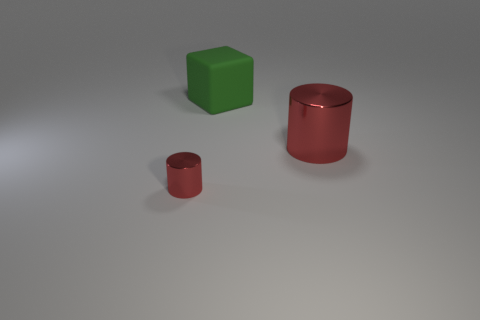Is there any other thing that is the same material as the big green object?
Offer a very short reply. No. There is a large object that is to the left of the big shiny thing; what is it made of?
Provide a succinct answer. Rubber. How many other objects are there of the same shape as the green thing?
Give a very brief answer. 0. Is the shape of the large matte object the same as the tiny object?
Your answer should be compact. No. Are there any large red cylinders behind the tiny metallic cylinder?
Keep it short and to the point. Yes. What number of objects are large red metal cylinders or large yellow rubber objects?
Provide a succinct answer. 1. How many other objects are the same size as the green block?
Offer a terse response. 1. What number of objects are both in front of the big green object and on the left side of the big red metal thing?
Make the answer very short. 1. Does the cylinder right of the green rubber block have the same size as the green cube to the right of the tiny red metallic object?
Your answer should be very brief. Yes. What size is the thing behind the big red metal cylinder?
Keep it short and to the point. Large. 